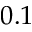Convert formula to latex. <formula><loc_0><loc_0><loc_500><loc_500>0 . 1</formula> 